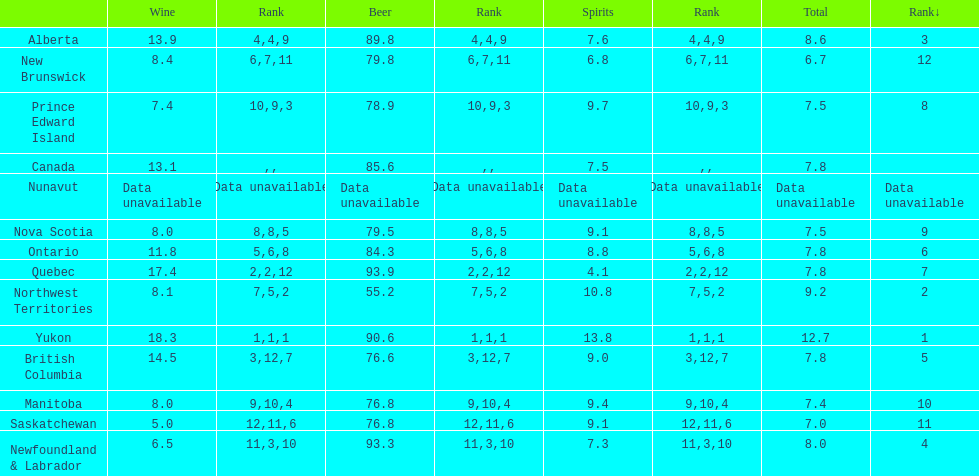How many litres do individuals in yukon consume in spirits per year? 12.7. 